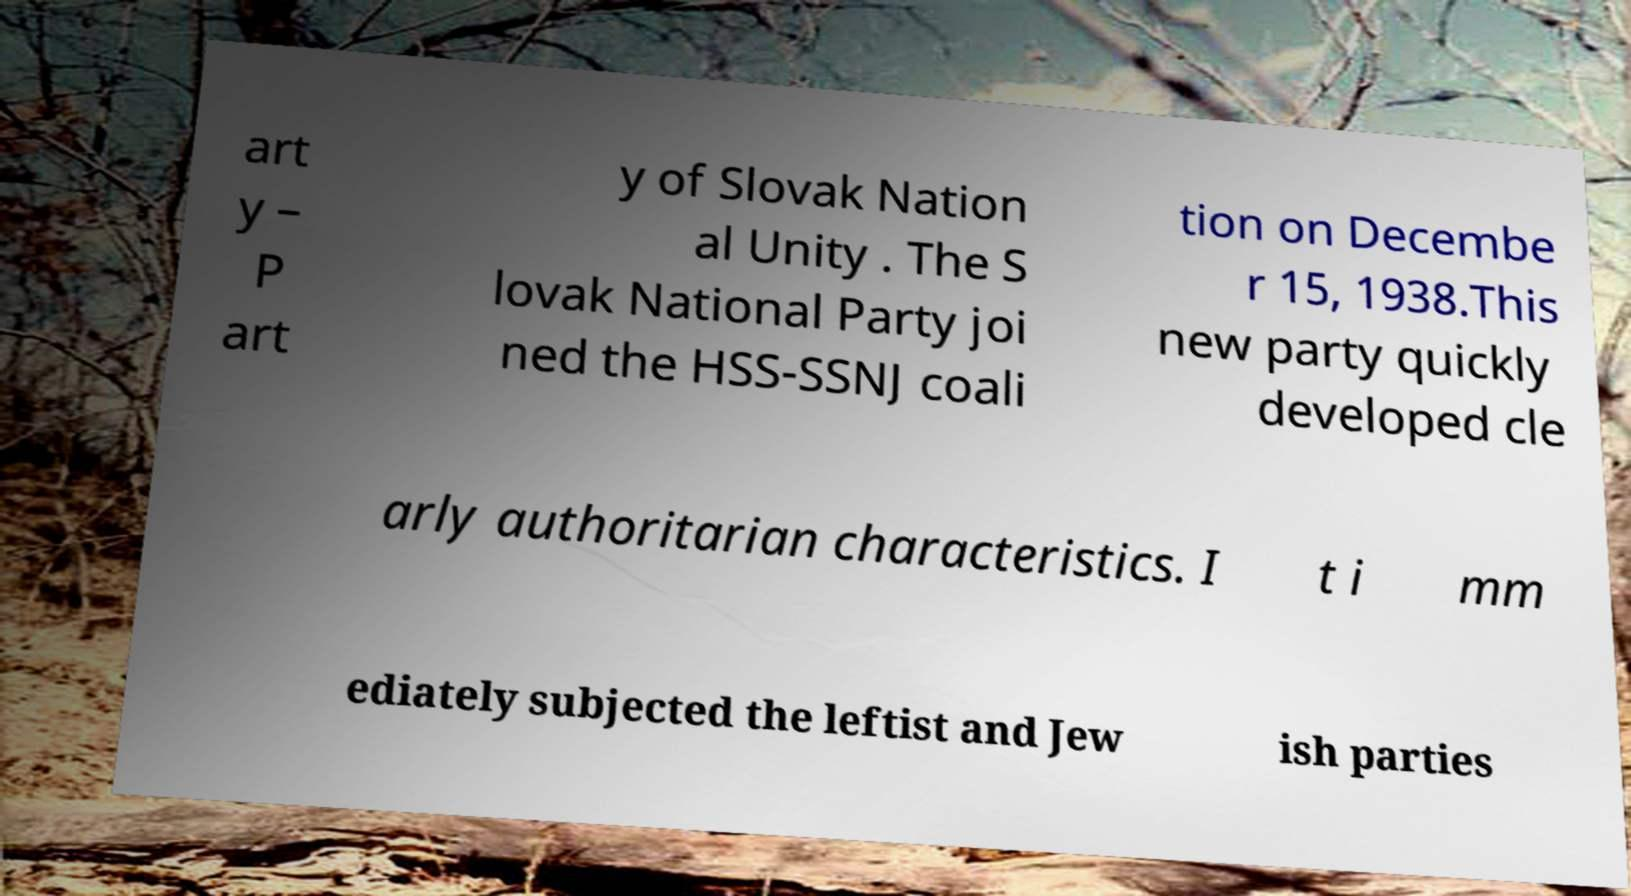Can you read and provide the text displayed in the image?This photo seems to have some interesting text. Can you extract and type it out for me? art y – P art y of Slovak Nation al Unity . The S lovak National Party joi ned the HSS-SSNJ coali tion on Decembe r 15, 1938.This new party quickly developed cle arly authoritarian characteristics. I t i mm ediately subjected the leftist and Jew ish parties 